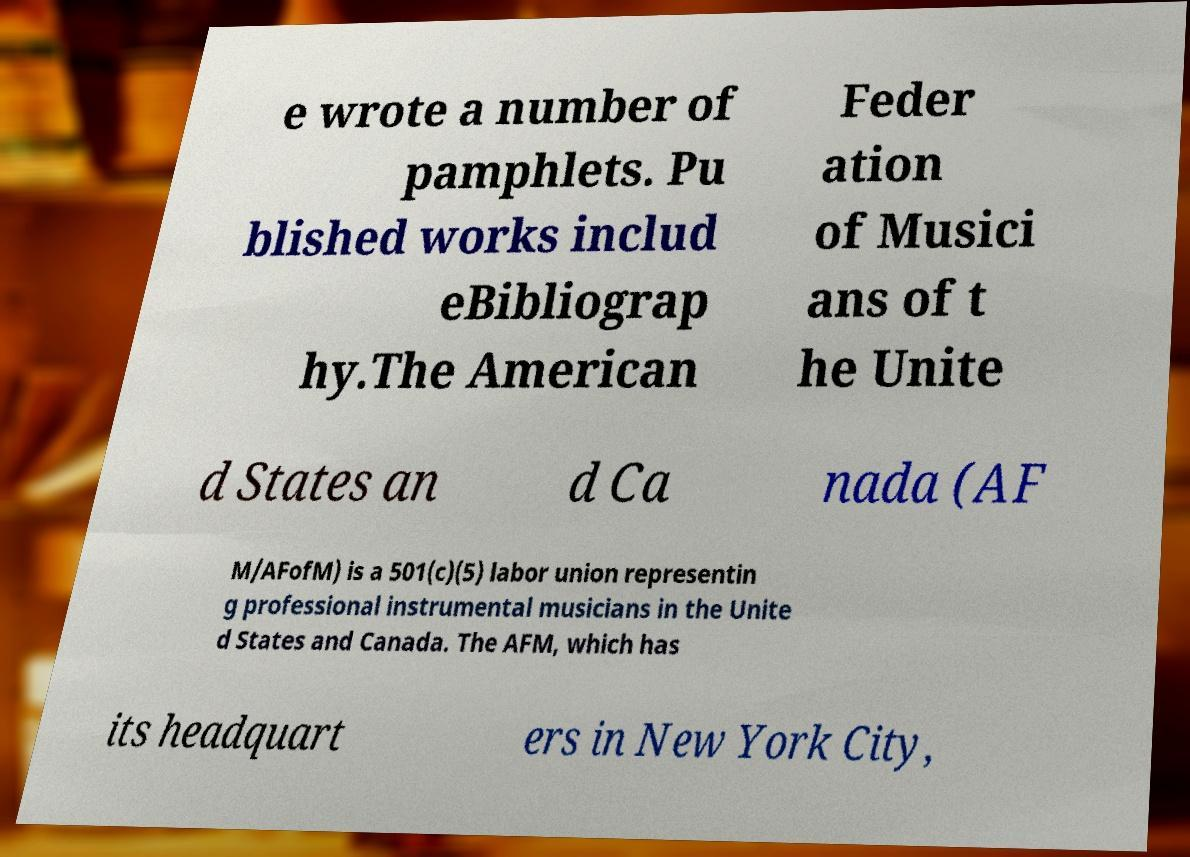Can you accurately transcribe the text from the provided image for me? e wrote a number of pamphlets. Pu blished works includ eBibliograp hy.The American Feder ation of Musici ans of t he Unite d States an d Ca nada (AF M/AFofM) is a 501(c)(5) labor union representin g professional instrumental musicians in the Unite d States and Canada. The AFM, which has its headquart ers in New York City, 